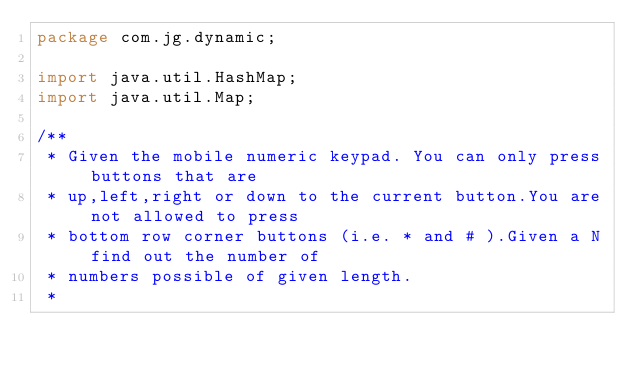<code> <loc_0><loc_0><loc_500><loc_500><_Java_>package com.jg.dynamic;

import java.util.HashMap;
import java.util.Map;

/**
 * Given the mobile numeric keypad. You can only press buttons that are
 * up,left,right or down to the current button.You are not allowed to press
 * bottom row corner buttons (i.e. * and # ).Given a N find out the number of
 * numbers possible of given length.
 * </code> 